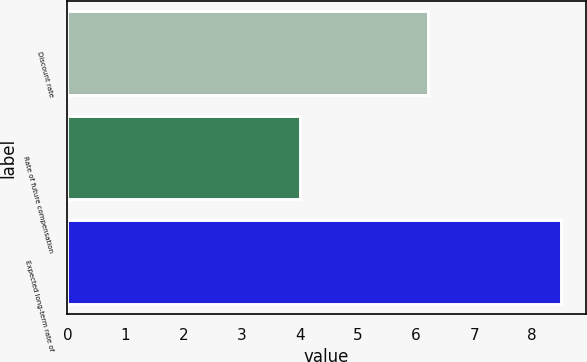Convert chart to OTSL. <chart><loc_0><loc_0><loc_500><loc_500><bar_chart><fcel>Discount rate<fcel>Rate of future compensation<fcel>Expected long-term rate of<nl><fcel>6.2<fcel>4<fcel>8.5<nl></chart> 